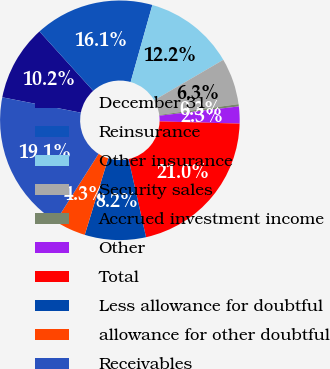<chart> <loc_0><loc_0><loc_500><loc_500><pie_chart><fcel>December 31<fcel>Reinsurance<fcel>Other insurance<fcel>Security sales<fcel>Accrued investment income<fcel>Other<fcel>Total<fcel>Less allowance for doubtful<fcel>allowance for other doubtful<fcel>Receivables<nl><fcel>10.22%<fcel>16.08%<fcel>12.21%<fcel>6.26%<fcel>0.31%<fcel>2.29%<fcel>21.05%<fcel>8.24%<fcel>4.27%<fcel>19.07%<nl></chart> 